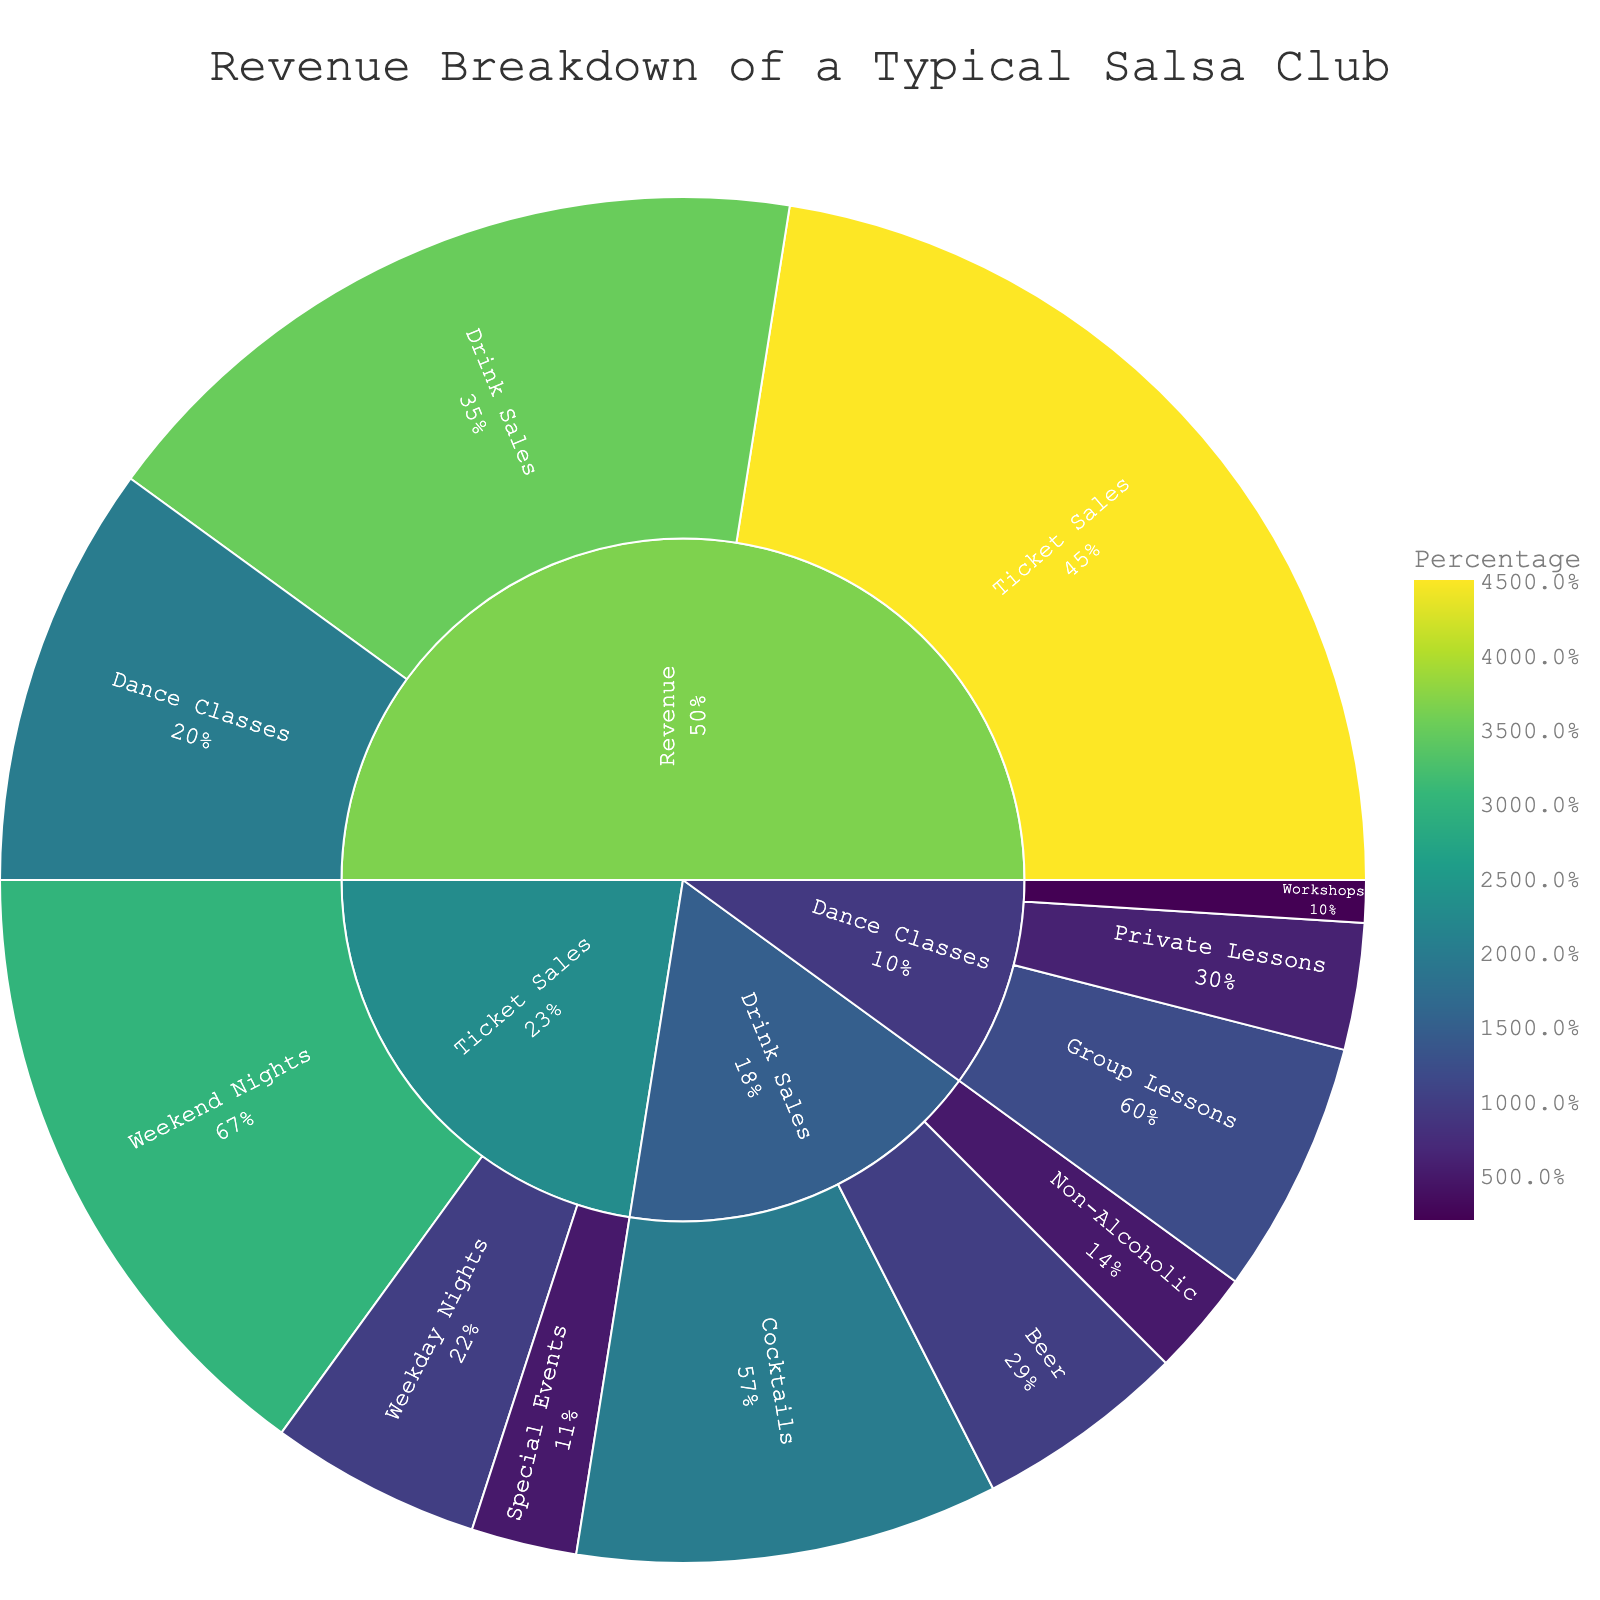what is the largest subcategory in the Revenue category? The largest subcategory is the one with the highest value within the main category 'Revenue'. Referring to the figure, 'Ticket Sales' has the highest value of 45.
Answer: Ticket Sales What percentage of total revenue comes from Drink Sales? To determine the percentage, divide the value of 'Drink Sales' by the total value of the 'Revenue' category and then convert it to a percentage. The total revenue is 100 (45 + 35 + 20). Drink Sales is 35, so (35/100)*100% = 35%.
Answer: 35% Which subcategory contributes more to Ticket Sales: Weekend Nights or Weekday Nights? Compare the values of 'Weekend Nights' and 'Weekday Nights' under 'Ticket Sales'. 'Weekend Nights' has a value of 30, while 'Weekday Nights' has a value of 10, so Weekend Nights contributes more.
Answer: Weekend Nights What is the combined value of Private Lessons and Workshops under Dance Classes? Add the values of 'Private Lessons' (6) and 'Workshops' (2), which fall under 'Dance Classes'. The combined value is 6 + 2.
Answer: 8 How does the contribution of Special Events to Ticket Sales compare to that of Non-Alcoholic drinks to Drink Sales? Compare the value of 'Special Events' (5) under 'Ticket Sales' to the value of 'Non-Alcoholic' (5) under 'Drink Sales'. Both have the same value of 5.
Answer: Equal By how much does the value of Cocktails exceed that of Non-Alcoholic drinks? Subtract the value of 'Non-Alcoholic drinks' (5) from the value of 'Cocktails' (20). So, 20 - 5 = 15.
Answer: 15 Does Group Lessons or Private Lessons contribute more to Dance Classes revenue? Compare the values of 'Group Lessons' (12) and 'Private Lessons' (6) under 'Dance Classes'. Group Lessons has a higher value.
Answer: Group Lessons Which has a higher revenue value, Weekday Nights under Ticket Sales or Beer under Drink Sales? Compare the values of 'Weekday Nights' (10) under 'Ticket Sales' and 'Beer' (10) under 'Drink Sales'. Both have the same value of 10.
Answer: Equal 